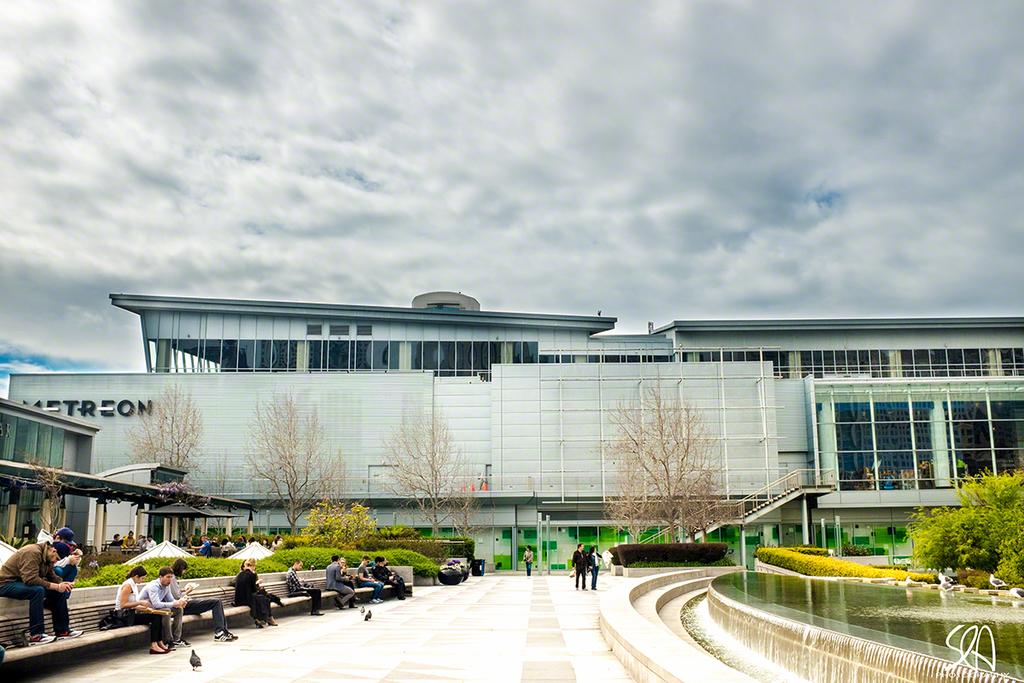What are the people in the image doing? The people in the image are sitting on benches. Where are the benches located in relation to the building? The benches are in front of a building. What other feature can be seen in the image? There is a fountain in the image. What type of vegetation is present in the image? Trees are present in the image. How would you describe the sky in the image? The sky appears gloomy in the image. What type of operation is being performed on the chair in the image? There is no chair present in the image, and therefore no operation is being performed on it. 